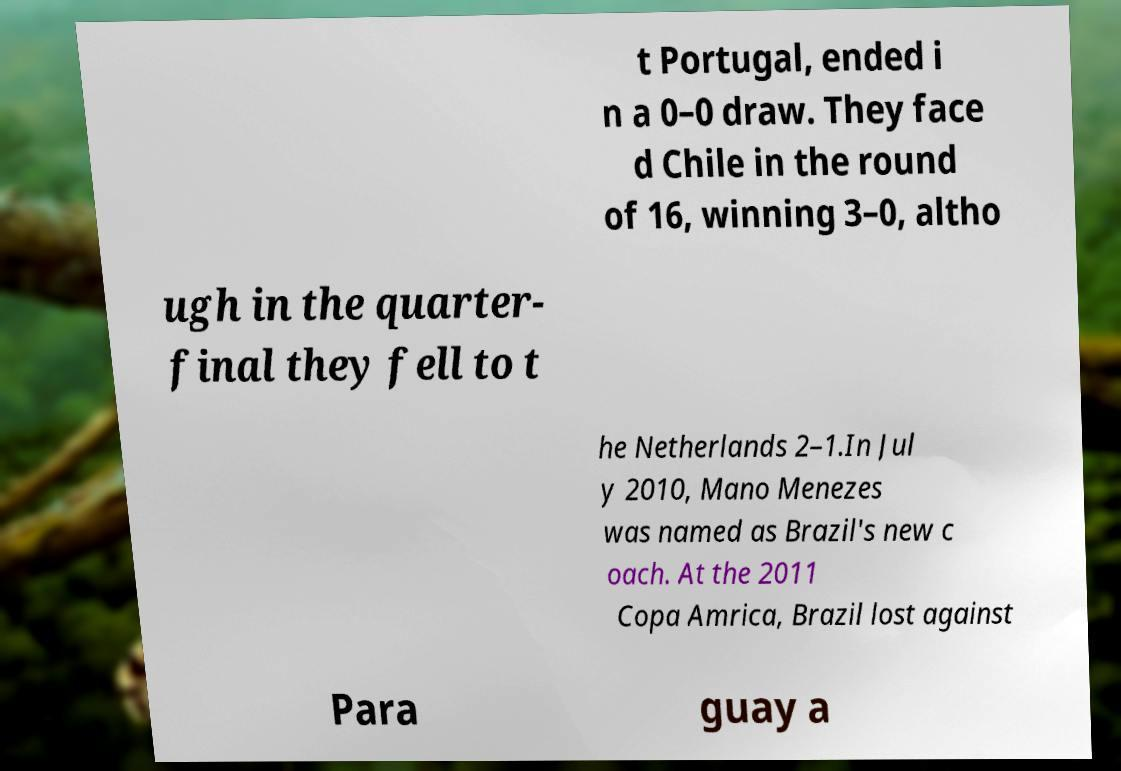Could you extract and type out the text from this image? t Portugal, ended i n a 0–0 draw. They face d Chile in the round of 16, winning 3–0, altho ugh in the quarter- final they fell to t he Netherlands 2–1.In Jul y 2010, Mano Menezes was named as Brazil's new c oach. At the 2011 Copa Amrica, Brazil lost against Para guay a 